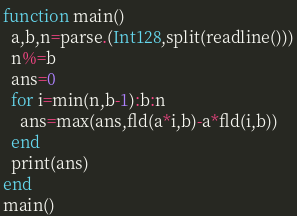Convert code to text. <code><loc_0><loc_0><loc_500><loc_500><_Julia_>function main()
  a,b,n=parse.(Int128,split(readline()))
  n%=b
  ans=0
  for i=min(n,b-1):b:n
    ans=max(ans,fld(a*i,b)-a*fld(i,b))
  end
  print(ans)
end
main()</code> 